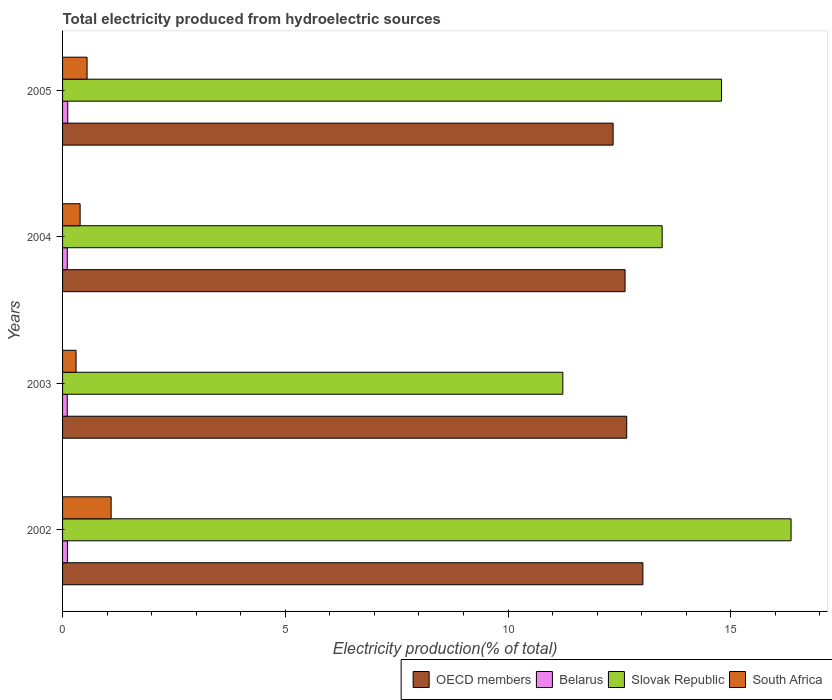How many groups of bars are there?
Make the answer very short. 4. How many bars are there on the 3rd tick from the top?
Offer a terse response. 4. What is the total electricity produced in Slovak Republic in 2004?
Your answer should be compact. 13.46. Across all years, what is the maximum total electricity produced in South Africa?
Ensure brevity in your answer.  1.09. Across all years, what is the minimum total electricity produced in South Africa?
Provide a succinct answer. 0.3. In which year was the total electricity produced in Slovak Republic maximum?
Give a very brief answer. 2002. What is the total total electricity produced in South Africa in the graph?
Give a very brief answer. 2.34. What is the difference between the total electricity produced in Slovak Republic in 2002 and that in 2004?
Offer a very short reply. 2.89. What is the difference between the total electricity produced in Belarus in 2005 and the total electricity produced in South Africa in 2003?
Make the answer very short. -0.19. What is the average total electricity produced in OECD members per year?
Your answer should be compact. 12.67. In the year 2002, what is the difference between the total electricity produced in South Africa and total electricity produced in OECD members?
Your response must be concise. -11.94. What is the ratio of the total electricity produced in Belarus in 2003 to that in 2004?
Your answer should be very brief. 0.99. Is the total electricity produced in Slovak Republic in 2003 less than that in 2004?
Provide a short and direct response. Yes. What is the difference between the highest and the second highest total electricity produced in Slovak Republic?
Offer a very short reply. 1.56. What is the difference between the highest and the lowest total electricity produced in Belarus?
Provide a succinct answer. 0.01. Is the sum of the total electricity produced in Slovak Republic in 2002 and 2003 greater than the maximum total electricity produced in Belarus across all years?
Your response must be concise. Yes. What does the 2nd bar from the top in 2004 represents?
Make the answer very short. Slovak Republic. Is it the case that in every year, the sum of the total electricity produced in OECD members and total electricity produced in Slovak Republic is greater than the total electricity produced in South Africa?
Your answer should be compact. Yes. Are all the bars in the graph horizontal?
Make the answer very short. Yes. How many years are there in the graph?
Your answer should be very brief. 4. Are the values on the major ticks of X-axis written in scientific E-notation?
Offer a terse response. No. Does the graph contain any zero values?
Offer a very short reply. No. How many legend labels are there?
Your answer should be very brief. 4. What is the title of the graph?
Your answer should be very brief. Total electricity produced from hydroelectric sources. What is the label or title of the X-axis?
Offer a terse response. Electricity production(% of total). What is the Electricity production(% of total) of OECD members in 2002?
Make the answer very short. 13.03. What is the Electricity production(% of total) in Belarus in 2002?
Ensure brevity in your answer.  0.11. What is the Electricity production(% of total) of Slovak Republic in 2002?
Provide a succinct answer. 16.35. What is the Electricity production(% of total) of South Africa in 2002?
Offer a very short reply. 1.09. What is the Electricity production(% of total) in OECD members in 2003?
Keep it short and to the point. 12.66. What is the Electricity production(% of total) of Belarus in 2003?
Your answer should be compact. 0.11. What is the Electricity production(% of total) in Slovak Republic in 2003?
Provide a succinct answer. 11.23. What is the Electricity production(% of total) in South Africa in 2003?
Make the answer very short. 0.3. What is the Electricity production(% of total) of OECD members in 2004?
Offer a terse response. 12.63. What is the Electricity production(% of total) in Belarus in 2004?
Your response must be concise. 0.11. What is the Electricity production(% of total) of Slovak Republic in 2004?
Offer a terse response. 13.46. What is the Electricity production(% of total) in South Africa in 2004?
Make the answer very short. 0.39. What is the Electricity production(% of total) of OECD members in 2005?
Your response must be concise. 12.36. What is the Electricity production(% of total) of Belarus in 2005?
Your answer should be compact. 0.12. What is the Electricity production(% of total) of Slovak Republic in 2005?
Make the answer very short. 14.79. What is the Electricity production(% of total) of South Africa in 2005?
Give a very brief answer. 0.55. Across all years, what is the maximum Electricity production(% of total) in OECD members?
Make the answer very short. 13.03. Across all years, what is the maximum Electricity production(% of total) of Belarus?
Your answer should be very brief. 0.12. Across all years, what is the maximum Electricity production(% of total) of Slovak Republic?
Ensure brevity in your answer.  16.35. Across all years, what is the maximum Electricity production(% of total) of South Africa?
Ensure brevity in your answer.  1.09. Across all years, what is the minimum Electricity production(% of total) in OECD members?
Keep it short and to the point. 12.36. Across all years, what is the minimum Electricity production(% of total) in Belarus?
Keep it short and to the point. 0.11. Across all years, what is the minimum Electricity production(% of total) of Slovak Republic?
Your answer should be compact. 11.23. Across all years, what is the minimum Electricity production(% of total) of South Africa?
Your answer should be very brief. 0.3. What is the total Electricity production(% of total) of OECD members in the graph?
Provide a succinct answer. 50.68. What is the total Electricity production(% of total) in Belarus in the graph?
Ensure brevity in your answer.  0.44. What is the total Electricity production(% of total) of Slovak Republic in the graph?
Provide a succinct answer. 55.84. What is the total Electricity production(% of total) in South Africa in the graph?
Keep it short and to the point. 2.34. What is the difference between the Electricity production(% of total) of OECD members in 2002 and that in 2003?
Ensure brevity in your answer.  0.36. What is the difference between the Electricity production(% of total) of Belarus in 2002 and that in 2003?
Your answer should be compact. 0. What is the difference between the Electricity production(% of total) of Slovak Republic in 2002 and that in 2003?
Your answer should be compact. 5.12. What is the difference between the Electricity production(% of total) in South Africa in 2002 and that in 2003?
Offer a very short reply. 0.79. What is the difference between the Electricity production(% of total) in OECD members in 2002 and that in 2004?
Your answer should be compact. 0.4. What is the difference between the Electricity production(% of total) in Belarus in 2002 and that in 2004?
Provide a short and direct response. 0. What is the difference between the Electricity production(% of total) in Slovak Republic in 2002 and that in 2004?
Provide a succinct answer. 2.89. What is the difference between the Electricity production(% of total) in South Africa in 2002 and that in 2004?
Offer a very short reply. 0.7. What is the difference between the Electricity production(% of total) in OECD members in 2002 and that in 2005?
Provide a succinct answer. 0.67. What is the difference between the Electricity production(% of total) of Belarus in 2002 and that in 2005?
Your response must be concise. -0.01. What is the difference between the Electricity production(% of total) of Slovak Republic in 2002 and that in 2005?
Offer a very short reply. 1.56. What is the difference between the Electricity production(% of total) of South Africa in 2002 and that in 2005?
Your response must be concise. 0.54. What is the difference between the Electricity production(% of total) in OECD members in 2003 and that in 2004?
Offer a very short reply. 0.04. What is the difference between the Electricity production(% of total) in Belarus in 2003 and that in 2004?
Give a very brief answer. -0. What is the difference between the Electricity production(% of total) of Slovak Republic in 2003 and that in 2004?
Ensure brevity in your answer.  -2.23. What is the difference between the Electricity production(% of total) of South Africa in 2003 and that in 2004?
Your response must be concise. -0.09. What is the difference between the Electricity production(% of total) of OECD members in 2003 and that in 2005?
Provide a short and direct response. 0.31. What is the difference between the Electricity production(% of total) of Belarus in 2003 and that in 2005?
Keep it short and to the point. -0.01. What is the difference between the Electricity production(% of total) of Slovak Republic in 2003 and that in 2005?
Your answer should be very brief. -3.56. What is the difference between the Electricity production(% of total) of South Africa in 2003 and that in 2005?
Offer a terse response. -0.25. What is the difference between the Electricity production(% of total) in OECD members in 2004 and that in 2005?
Ensure brevity in your answer.  0.27. What is the difference between the Electricity production(% of total) in Belarus in 2004 and that in 2005?
Your answer should be compact. -0.01. What is the difference between the Electricity production(% of total) of Slovak Republic in 2004 and that in 2005?
Keep it short and to the point. -1.33. What is the difference between the Electricity production(% of total) in South Africa in 2004 and that in 2005?
Your answer should be very brief. -0.16. What is the difference between the Electricity production(% of total) of OECD members in 2002 and the Electricity production(% of total) of Belarus in 2003?
Give a very brief answer. 12.92. What is the difference between the Electricity production(% of total) in OECD members in 2002 and the Electricity production(% of total) in Slovak Republic in 2003?
Keep it short and to the point. 1.8. What is the difference between the Electricity production(% of total) of OECD members in 2002 and the Electricity production(% of total) of South Africa in 2003?
Keep it short and to the point. 12.73. What is the difference between the Electricity production(% of total) of Belarus in 2002 and the Electricity production(% of total) of Slovak Republic in 2003?
Your answer should be very brief. -11.12. What is the difference between the Electricity production(% of total) in Belarus in 2002 and the Electricity production(% of total) in South Africa in 2003?
Ensure brevity in your answer.  -0.19. What is the difference between the Electricity production(% of total) of Slovak Republic in 2002 and the Electricity production(% of total) of South Africa in 2003?
Provide a short and direct response. 16.05. What is the difference between the Electricity production(% of total) of OECD members in 2002 and the Electricity production(% of total) of Belarus in 2004?
Provide a short and direct response. 12.92. What is the difference between the Electricity production(% of total) in OECD members in 2002 and the Electricity production(% of total) in Slovak Republic in 2004?
Make the answer very short. -0.43. What is the difference between the Electricity production(% of total) in OECD members in 2002 and the Electricity production(% of total) in South Africa in 2004?
Your answer should be compact. 12.63. What is the difference between the Electricity production(% of total) of Belarus in 2002 and the Electricity production(% of total) of Slovak Republic in 2004?
Keep it short and to the point. -13.35. What is the difference between the Electricity production(% of total) of Belarus in 2002 and the Electricity production(% of total) of South Africa in 2004?
Your response must be concise. -0.28. What is the difference between the Electricity production(% of total) of Slovak Republic in 2002 and the Electricity production(% of total) of South Africa in 2004?
Offer a terse response. 15.96. What is the difference between the Electricity production(% of total) in OECD members in 2002 and the Electricity production(% of total) in Belarus in 2005?
Your answer should be compact. 12.91. What is the difference between the Electricity production(% of total) of OECD members in 2002 and the Electricity production(% of total) of Slovak Republic in 2005?
Your response must be concise. -1.77. What is the difference between the Electricity production(% of total) in OECD members in 2002 and the Electricity production(% of total) in South Africa in 2005?
Give a very brief answer. 12.48. What is the difference between the Electricity production(% of total) of Belarus in 2002 and the Electricity production(% of total) of Slovak Republic in 2005?
Make the answer very short. -14.68. What is the difference between the Electricity production(% of total) in Belarus in 2002 and the Electricity production(% of total) in South Africa in 2005?
Offer a very short reply. -0.44. What is the difference between the Electricity production(% of total) of Slovak Republic in 2002 and the Electricity production(% of total) of South Africa in 2005?
Your answer should be compact. 15.8. What is the difference between the Electricity production(% of total) of OECD members in 2003 and the Electricity production(% of total) of Belarus in 2004?
Give a very brief answer. 12.56. What is the difference between the Electricity production(% of total) of OECD members in 2003 and the Electricity production(% of total) of Slovak Republic in 2004?
Give a very brief answer. -0.8. What is the difference between the Electricity production(% of total) of OECD members in 2003 and the Electricity production(% of total) of South Africa in 2004?
Provide a succinct answer. 12.27. What is the difference between the Electricity production(% of total) in Belarus in 2003 and the Electricity production(% of total) in Slovak Republic in 2004?
Your answer should be very brief. -13.36. What is the difference between the Electricity production(% of total) in Belarus in 2003 and the Electricity production(% of total) in South Africa in 2004?
Your answer should be compact. -0.29. What is the difference between the Electricity production(% of total) in Slovak Republic in 2003 and the Electricity production(% of total) in South Africa in 2004?
Offer a terse response. 10.84. What is the difference between the Electricity production(% of total) of OECD members in 2003 and the Electricity production(% of total) of Belarus in 2005?
Ensure brevity in your answer.  12.55. What is the difference between the Electricity production(% of total) in OECD members in 2003 and the Electricity production(% of total) in Slovak Republic in 2005?
Make the answer very short. -2.13. What is the difference between the Electricity production(% of total) of OECD members in 2003 and the Electricity production(% of total) of South Africa in 2005?
Keep it short and to the point. 12.11. What is the difference between the Electricity production(% of total) of Belarus in 2003 and the Electricity production(% of total) of Slovak Republic in 2005?
Your answer should be very brief. -14.69. What is the difference between the Electricity production(% of total) in Belarus in 2003 and the Electricity production(% of total) in South Africa in 2005?
Keep it short and to the point. -0.45. What is the difference between the Electricity production(% of total) in Slovak Republic in 2003 and the Electricity production(% of total) in South Africa in 2005?
Give a very brief answer. 10.68. What is the difference between the Electricity production(% of total) in OECD members in 2004 and the Electricity production(% of total) in Belarus in 2005?
Offer a very short reply. 12.51. What is the difference between the Electricity production(% of total) of OECD members in 2004 and the Electricity production(% of total) of Slovak Republic in 2005?
Ensure brevity in your answer.  -2.17. What is the difference between the Electricity production(% of total) in OECD members in 2004 and the Electricity production(% of total) in South Africa in 2005?
Offer a very short reply. 12.08. What is the difference between the Electricity production(% of total) of Belarus in 2004 and the Electricity production(% of total) of Slovak Republic in 2005?
Provide a short and direct response. -14.69. What is the difference between the Electricity production(% of total) in Belarus in 2004 and the Electricity production(% of total) in South Africa in 2005?
Your answer should be compact. -0.44. What is the difference between the Electricity production(% of total) of Slovak Republic in 2004 and the Electricity production(% of total) of South Africa in 2005?
Ensure brevity in your answer.  12.91. What is the average Electricity production(% of total) in OECD members per year?
Keep it short and to the point. 12.67. What is the average Electricity production(% of total) in Belarus per year?
Your answer should be very brief. 0.11. What is the average Electricity production(% of total) in Slovak Republic per year?
Give a very brief answer. 13.96. What is the average Electricity production(% of total) of South Africa per year?
Provide a short and direct response. 0.58. In the year 2002, what is the difference between the Electricity production(% of total) of OECD members and Electricity production(% of total) of Belarus?
Provide a succinct answer. 12.92. In the year 2002, what is the difference between the Electricity production(% of total) in OECD members and Electricity production(% of total) in Slovak Republic?
Provide a short and direct response. -3.33. In the year 2002, what is the difference between the Electricity production(% of total) of OECD members and Electricity production(% of total) of South Africa?
Make the answer very short. 11.94. In the year 2002, what is the difference between the Electricity production(% of total) in Belarus and Electricity production(% of total) in Slovak Republic?
Your answer should be compact. -16.24. In the year 2002, what is the difference between the Electricity production(% of total) of Belarus and Electricity production(% of total) of South Africa?
Provide a succinct answer. -0.98. In the year 2002, what is the difference between the Electricity production(% of total) in Slovak Republic and Electricity production(% of total) in South Africa?
Make the answer very short. 15.26. In the year 2003, what is the difference between the Electricity production(% of total) of OECD members and Electricity production(% of total) of Belarus?
Offer a very short reply. 12.56. In the year 2003, what is the difference between the Electricity production(% of total) of OECD members and Electricity production(% of total) of Slovak Republic?
Your answer should be very brief. 1.43. In the year 2003, what is the difference between the Electricity production(% of total) in OECD members and Electricity production(% of total) in South Africa?
Provide a short and direct response. 12.36. In the year 2003, what is the difference between the Electricity production(% of total) of Belarus and Electricity production(% of total) of Slovak Republic?
Offer a very short reply. -11.13. In the year 2003, what is the difference between the Electricity production(% of total) in Belarus and Electricity production(% of total) in South Africa?
Offer a very short reply. -0.2. In the year 2003, what is the difference between the Electricity production(% of total) in Slovak Republic and Electricity production(% of total) in South Africa?
Ensure brevity in your answer.  10.93. In the year 2004, what is the difference between the Electricity production(% of total) in OECD members and Electricity production(% of total) in Belarus?
Provide a short and direct response. 12.52. In the year 2004, what is the difference between the Electricity production(% of total) of OECD members and Electricity production(% of total) of Slovak Republic?
Keep it short and to the point. -0.83. In the year 2004, what is the difference between the Electricity production(% of total) of OECD members and Electricity production(% of total) of South Africa?
Ensure brevity in your answer.  12.23. In the year 2004, what is the difference between the Electricity production(% of total) in Belarus and Electricity production(% of total) in Slovak Republic?
Provide a short and direct response. -13.35. In the year 2004, what is the difference between the Electricity production(% of total) in Belarus and Electricity production(% of total) in South Africa?
Keep it short and to the point. -0.29. In the year 2004, what is the difference between the Electricity production(% of total) of Slovak Republic and Electricity production(% of total) of South Africa?
Make the answer very short. 13.07. In the year 2005, what is the difference between the Electricity production(% of total) of OECD members and Electricity production(% of total) of Belarus?
Provide a succinct answer. 12.24. In the year 2005, what is the difference between the Electricity production(% of total) of OECD members and Electricity production(% of total) of Slovak Republic?
Your answer should be compact. -2.43. In the year 2005, what is the difference between the Electricity production(% of total) of OECD members and Electricity production(% of total) of South Africa?
Provide a succinct answer. 11.81. In the year 2005, what is the difference between the Electricity production(% of total) in Belarus and Electricity production(% of total) in Slovak Republic?
Give a very brief answer. -14.68. In the year 2005, what is the difference between the Electricity production(% of total) of Belarus and Electricity production(% of total) of South Africa?
Your answer should be compact. -0.43. In the year 2005, what is the difference between the Electricity production(% of total) of Slovak Republic and Electricity production(% of total) of South Africa?
Your answer should be very brief. 14.24. What is the ratio of the Electricity production(% of total) in OECD members in 2002 to that in 2003?
Keep it short and to the point. 1.03. What is the ratio of the Electricity production(% of total) of Belarus in 2002 to that in 2003?
Provide a succinct answer. 1.04. What is the ratio of the Electricity production(% of total) in Slovak Republic in 2002 to that in 2003?
Your answer should be very brief. 1.46. What is the ratio of the Electricity production(% of total) of South Africa in 2002 to that in 2003?
Give a very brief answer. 3.6. What is the ratio of the Electricity production(% of total) in OECD members in 2002 to that in 2004?
Give a very brief answer. 1.03. What is the ratio of the Electricity production(% of total) of Belarus in 2002 to that in 2004?
Make the answer very short. 1.04. What is the ratio of the Electricity production(% of total) in Slovak Republic in 2002 to that in 2004?
Offer a terse response. 1.22. What is the ratio of the Electricity production(% of total) in South Africa in 2002 to that in 2004?
Provide a short and direct response. 2.77. What is the ratio of the Electricity production(% of total) in OECD members in 2002 to that in 2005?
Keep it short and to the point. 1.05. What is the ratio of the Electricity production(% of total) in Belarus in 2002 to that in 2005?
Make the answer very short. 0.94. What is the ratio of the Electricity production(% of total) in Slovak Republic in 2002 to that in 2005?
Make the answer very short. 1.11. What is the ratio of the Electricity production(% of total) of South Africa in 2002 to that in 2005?
Your response must be concise. 1.98. What is the ratio of the Electricity production(% of total) of Slovak Republic in 2003 to that in 2004?
Ensure brevity in your answer.  0.83. What is the ratio of the Electricity production(% of total) of South Africa in 2003 to that in 2004?
Offer a very short reply. 0.77. What is the ratio of the Electricity production(% of total) of OECD members in 2003 to that in 2005?
Make the answer very short. 1.02. What is the ratio of the Electricity production(% of total) of Belarus in 2003 to that in 2005?
Offer a very short reply. 0.9. What is the ratio of the Electricity production(% of total) in Slovak Republic in 2003 to that in 2005?
Provide a succinct answer. 0.76. What is the ratio of the Electricity production(% of total) in South Africa in 2003 to that in 2005?
Your answer should be very brief. 0.55. What is the ratio of the Electricity production(% of total) in OECD members in 2004 to that in 2005?
Give a very brief answer. 1.02. What is the ratio of the Electricity production(% of total) in Belarus in 2004 to that in 2005?
Offer a very short reply. 0.91. What is the ratio of the Electricity production(% of total) of Slovak Republic in 2004 to that in 2005?
Your response must be concise. 0.91. What is the ratio of the Electricity production(% of total) in South Africa in 2004 to that in 2005?
Your answer should be very brief. 0.72. What is the difference between the highest and the second highest Electricity production(% of total) in OECD members?
Give a very brief answer. 0.36. What is the difference between the highest and the second highest Electricity production(% of total) in Belarus?
Give a very brief answer. 0.01. What is the difference between the highest and the second highest Electricity production(% of total) in Slovak Republic?
Make the answer very short. 1.56. What is the difference between the highest and the second highest Electricity production(% of total) of South Africa?
Your answer should be very brief. 0.54. What is the difference between the highest and the lowest Electricity production(% of total) of OECD members?
Offer a very short reply. 0.67. What is the difference between the highest and the lowest Electricity production(% of total) in Belarus?
Your answer should be compact. 0.01. What is the difference between the highest and the lowest Electricity production(% of total) in Slovak Republic?
Provide a succinct answer. 5.12. What is the difference between the highest and the lowest Electricity production(% of total) of South Africa?
Provide a succinct answer. 0.79. 